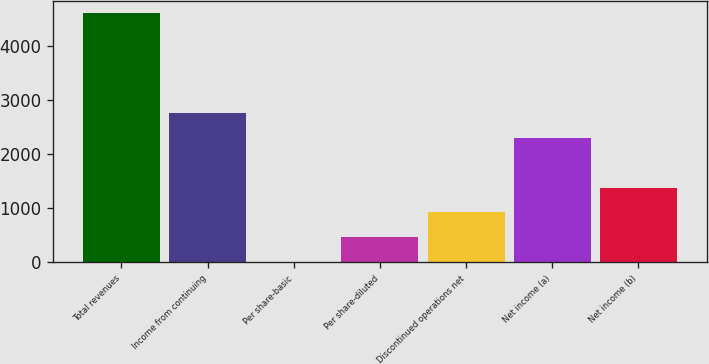<chart> <loc_0><loc_0><loc_500><loc_500><bar_chart><fcel>Total revenues<fcel>Income from continuing<fcel>Per share-basic<fcel>Per share-diluted<fcel>Discontinued operations net<fcel>Net income (a)<fcel>Net income (b)<nl><fcel>4613<fcel>2768.27<fcel>1.19<fcel>462.37<fcel>923.55<fcel>2307.09<fcel>1384.73<nl></chart> 